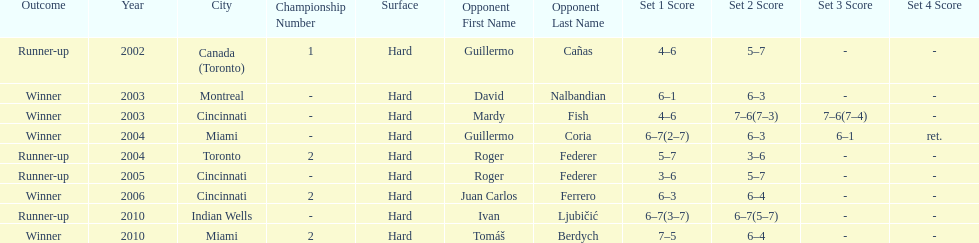What was the highest number of consecutive wins? 3. 